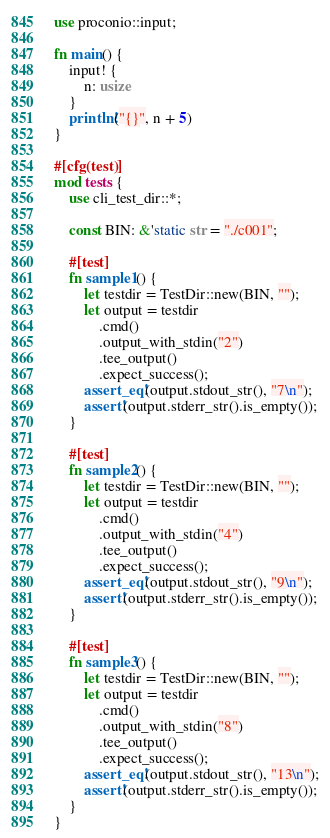Convert code to text. <code><loc_0><loc_0><loc_500><loc_500><_Rust_>use proconio::input;

fn main() {
    input! {
        n: usize
    }
    println!("{}", n + 5)
}

#[cfg(test)]
mod tests {
    use cli_test_dir::*;

    const BIN: &'static str = "./c001";

    #[test]
    fn sample1() {
        let testdir = TestDir::new(BIN, "");
        let output = testdir
            .cmd()
            .output_with_stdin("2")
            .tee_output()
            .expect_success();
        assert_eq!(output.stdout_str(), "7\n");
        assert!(output.stderr_str().is_empty());
    }

    #[test]
    fn sample2() {
        let testdir = TestDir::new(BIN, "");
        let output = testdir
            .cmd()
            .output_with_stdin("4")
            .tee_output()
            .expect_success();
        assert_eq!(output.stdout_str(), "9\n");
        assert!(output.stderr_str().is_empty());
    }

    #[test]
    fn sample3() {
        let testdir = TestDir::new(BIN, "");
        let output = testdir
            .cmd()
            .output_with_stdin("8")
            .tee_output()
            .expect_success();
        assert_eq!(output.stdout_str(), "13\n");
        assert!(output.stderr_str().is_empty());
    }
}
</code> 